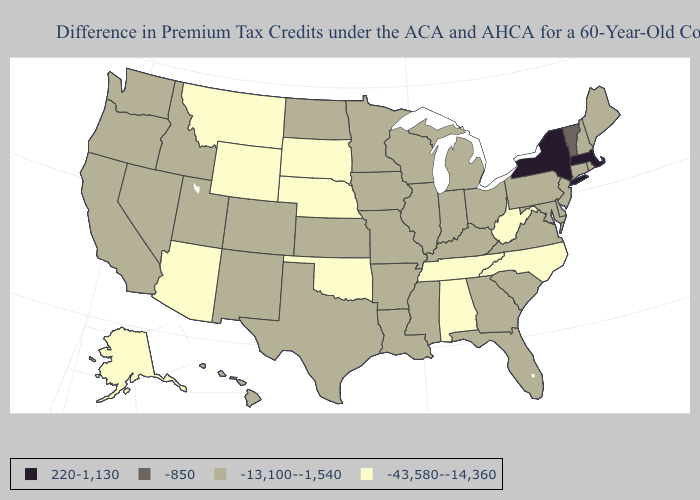Which states have the lowest value in the USA?
Give a very brief answer. Alabama, Alaska, Arizona, Montana, Nebraska, North Carolina, Oklahoma, South Dakota, Tennessee, West Virginia, Wyoming. Name the states that have a value in the range -13,100--1,540?
Answer briefly. Arkansas, California, Colorado, Connecticut, Delaware, Florida, Georgia, Hawaii, Idaho, Illinois, Indiana, Iowa, Kansas, Kentucky, Louisiana, Maine, Maryland, Michigan, Minnesota, Mississippi, Missouri, Nevada, New Hampshire, New Jersey, New Mexico, North Dakota, Ohio, Oregon, Pennsylvania, Rhode Island, South Carolina, Texas, Utah, Virginia, Washington, Wisconsin. Does New York have the same value as Kansas?
Concise answer only. No. What is the lowest value in states that border Mississippi?
Give a very brief answer. -43,580--14,360. Name the states that have a value in the range -43,580--14,360?
Quick response, please. Alabama, Alaska, Arizona, Montana, Nebraska, North Carolina, Oklahoma, South Dakota, Tennessee, West Virginia, Wyoming. Does the first symbol in the legend represent the smallest category?
Write a very short answer. No. Name the states that have a value in the range -13,100--1,540?
Short answer required. Arkansas, California, Colorado, Connecticut, Delaware, Florida, Georgia, Hawaii, Idaho, Illinois, Indiana, Iowa, Kansas, Kentucky, Louisiana, Maine, Maryland, Michigan, Minnesota, Mississippi, Missouri, Nevada, New Hampshire, New Jersey, New Mexico, North Dakota, Ohio, Oregon, Pennsylvania, Rhode Island, South Carolina, Texas, Utah, Virginia, Washington, Wisconsin. Is the legend a continuous bar?
Be succinct. No. Which states have the highest value in the USA?
Give a very brief answer. Massachusetts, New York. Name the states that have a value in the range -850?
Write a very short answer. Vermont. Does the first symbol in the legend represent the smallest category?
Quick response, please. No. Does the map have missing data?
Answer briefly. No. What is the highest value in states that border Georgia?
Short answer required. -13,100--1,540. Which states have the lowest value in the Northeast?
Answer briefly. Connecticut, Maine, New Hampshire, New Jersey, Pennsylvania, Rhode Island. 